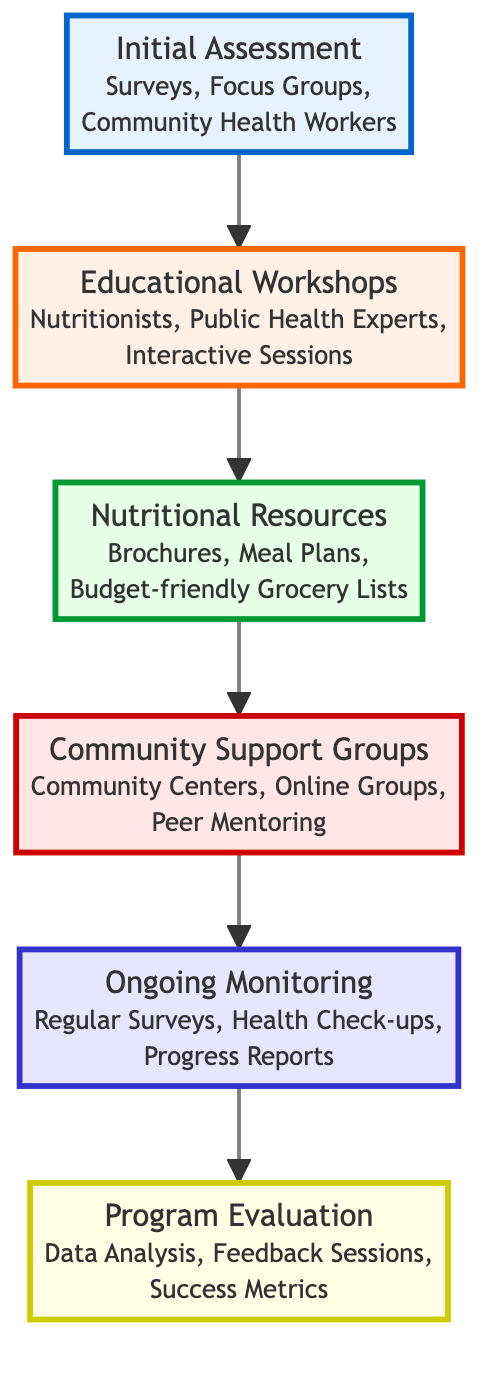What is the first step in the flow chart? The first step in the flow chart is labeled "Initial Assessment," which signifies that it is the starting point of the campaign.
Answer: Initial Assessment How many levels are in the flow chart? The diagram illustrates a total of six levels, each representing a different phase of the nutritional awareness campaign.
Answer: 6 What entities are associated with "Ongoing Monitoring"? The "Ongoing Monitoring" step includes entities such as "Regular Surveys," "Health Check-ups," and "Progress Reports," which are key components for tracking progress.
Answer: Regular Surveys, Health Check-ups, Progress Reports Which level follows "Nutritional Resources"? The level that follows "Nutritional Resources" is "Community Support Groups," indicating a progression from providing resources to building community support.
Answer: Community Support Groups What is the last step of the flow chart? The final step of the flow chart is "Program Evaluation," which indicates that the campaign concludes with assessing its effectiveness.
Answer: Program Evaluation What is the main goal of the "Educational Workshops"? The main goal of the "Educational Workshops" is to educate families about balanced diets and the importance of various nutrients, providing essential nutritional information.
Answer: Educate families How do "Community Support Groups" relate to "Educational Workshops"? "Community Support Groups" are formed after "Educational Workshops," highlighting the relationship between education and community engagement in promoting healthy habits.
Answer: Form after What kind of resources are provided in the "Nutritional Resources" step? The resources provided in the "Nutritional Resources" step include brochures, meal plans, and budget-friendly grocery lists, tailored to assist low-income families.
Answer: Brochures, Meal Plans, Budget-friendly Grocery Lists What is the purpose of "Program Evaluation"? The purpose of "Program Evaluation" is to evaluate the overall effectiveness of the campaign and identify areas for future improvement, ensuring the initiative remains impactful.
Answer: Evaluate effectiveness 